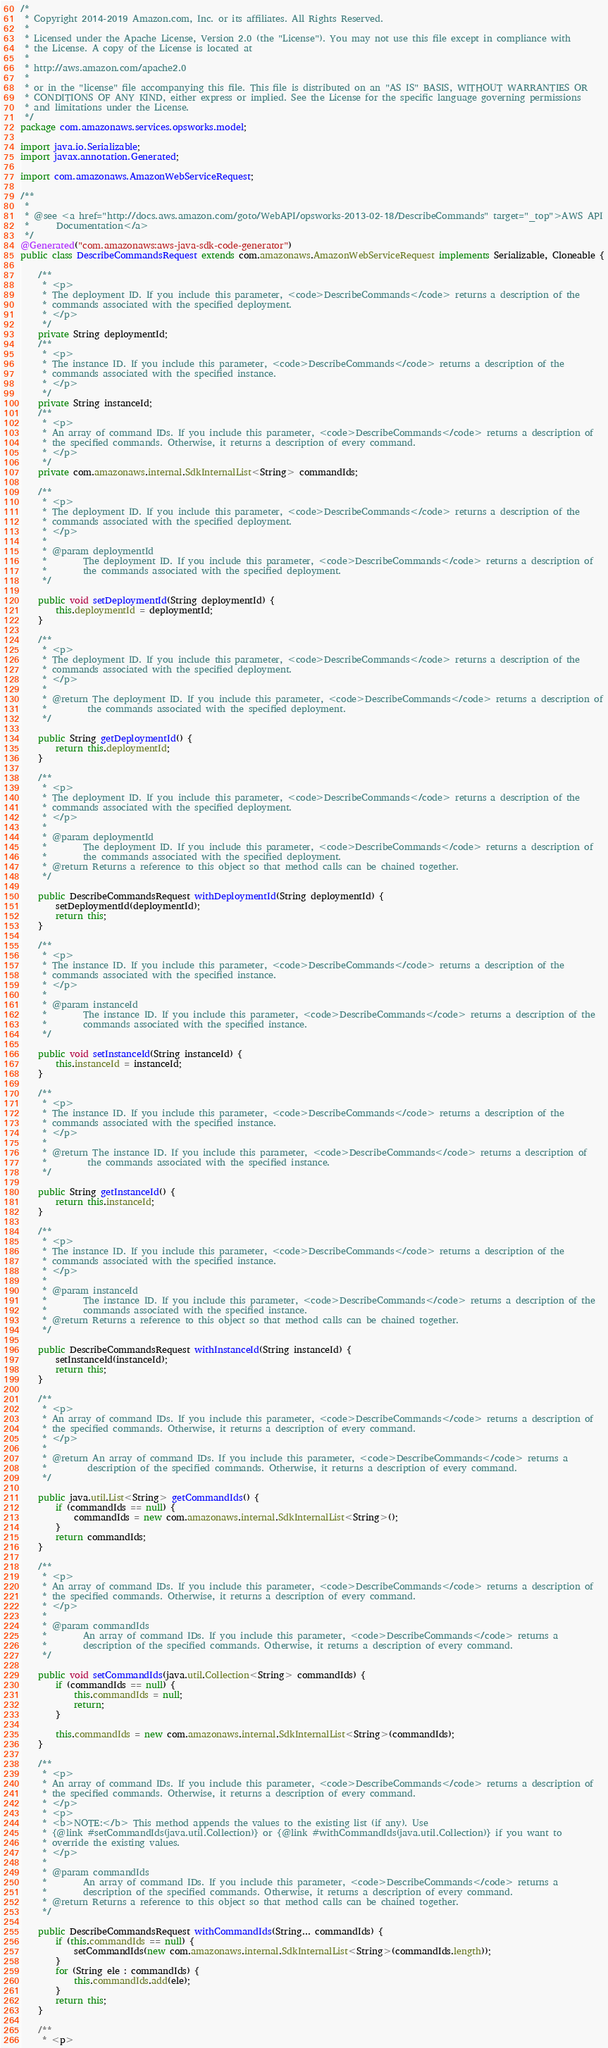Convert code to text. <code><loc_0><loc_0><loc_500><loc_500><_Java_>/*
 * Copyright 2014-2019 Amazon.com, Inc. or its affiliates. All Rights Reserved.
 * 
 * Licensed under the Apache License, Version 2.0 (the "License"). You may not use this file except in compliance with
 * the License. A copy of the License is located at
 * 
 * http://aws.amazon.com/apache2.0
 * 
 * or in the "license" file accompanying this file. This file is distributed on an "AS IS" BASIS, WITHOUT WARRANTIES OR
 * CONDITIONS OF ANY KIND, either express or implied. See the License for the specific language governing permissions
 * and limitations under the License.
 */
package com.amazonaws.services.opsworks.model;

import java.io.Serializable;
import javax.annotation.Generated;

import com.amazonaws.AmazonWebServiceRequest;

/**
 * 
 * @see <a href="http://docs.aws.amazon.com/goto/WebAPI/opsworks-2013-02-18/DescribeCommands" target="_top">AWS API
 *      Documentation</a>
 */
@Generated("com.amazonaws:aws-java-sdk-code-generator")
public class DescribeCommandsRequest extends com.amazonaws.AmazonWebServiceRequest implements Serializable, Cloneable {

    /**
     * <p>
     * The deployment ID. If you include this parameter, <code>DescribeCommands</code> returns a description of the
     * commands associated with the specified deployment.
     * </p>
     */
    private String deploymentId;
    /**
     * <p>
     * The instance ID. If you include this parameter, <code>DescribeCommands</code> returns a description of the
     * commands associated with the specified instance.
     * </p>
     */
    private String instanceId;
    /**
     * <p>
     * An array of command IDs. If you include this parameter, <code>DescribeCommands</code> returns a description of
     * the specified commands. Otherwise, it returns a description of every command.
     * </p>
     */
    private com.amazonaws.internal.SdkInternalList<String> commandIds;

    /**
     * <p>
     * The deployment ID. If you include this parameter, <code>DescribeCommands</code> returns a description of the
     * commands associated with the specified deployment.
     * </p>
     * 
     * @param deploymentId
     *        The deployment ID. If you include this parameter, <code>DescribeCommands</code> returns a description of
     *        the commands associated with the specified deployment.
     */

    public void setDeploymentId(String deploymentId) {
        this.deploymentId = deploymentId;
    }

    /**
     * <p>
     * The deployment ID. If you include this parameter, <code>DescribeCommands</code> returns a description of the
     * commands associated with the specified deployment.
     * </p>
     * 
     * @return The deployment ID. If you include this parameter, <code>DescribeCommands</code> returns a description of
     *         the commands associated with the specified deployment.
     */

    public String getDeploymentId() {
        return this.deploymentId;
    }

    /**
     * <p>
     * The deployment ID. If you include this parameter, <code>DescribeCommands</code> returns a description of the
     * commands associated with the specified deployment.
     * </p>
     * 
     * @param deploymentId
     *        The deployment ID. If you include this parameter, <code>DescribeCommands</code> returns a description of
     *        the commands associated with the specified deployment.
     * @return Returns a reference to this object so that method calls can be chained together.
     */

    public DescribeCommandsRequest withDeploymentId(String deploymentId) {
        setDeploymentId(deploymentId);
        return this;
    }

    /**
     * <p>
     * The instance ID. If you include this parameter, <code>DescribeCommands</code> returns a description of the
     * commands associated with the specified instance.
     * </p>
     * 
     * @param instanceId
     *        The instance ID. If you include this parameter, <code>DescribeCommands</code> returns a description of the
     *        commands associated with the specified instance.
     */

    public void setInstanceId(String instanceId) {
        this.instanceId = instanceId;
    }

    /**
     * <p>
     * The instance ID. If you include this parameter, <code>DescribeCommands</code> returns a description of the
     * commands associated with the specified instance.
     * </p>
     * 
     * @return The instance ID. If you include this parameter, <code>DescribeCommands</code> returns a description of
     *         the commands associated with the specified instance.
     */

    public String getInstanceId() {
        return this.instanceId;
    }

    /**
     * <p>
     * The instance ID. If you include this parameter, <code>DescribeCommands</code> returns a description of the
     * commands associated with the specified instance.
     * </p>
     * 
     * @param instanceId
     *        The instance ID. If you include this parameter, <code>DescribeCommands</code> returns a description of the
     *        commands associated with the specified instance.
     * @return Returns a reference to this object so that method calls can be chained together.
     */

    public DescribeCommandsRequest withInstanceId(String instanceId) {
        setInstanceId(instanceId);
        return this;
    }

    /**
     * <p>
     * An array of command IDs. If you include this parameter, <code>DescribeCommands</code> returns a description of
     * the specified commands. Otherwise, it returns a description of every command.
     * </p>
     * 
     * @return An array of command IDs. If you include this parameter, <code>DescribeCommands</code> returns a
     *         description of the specified commands. Otherwise, it returns a description of every command.
     */

    public java.util.List<String> getCommandIds() {
        if (commandIds == null) {
            commandIds = new com.amazonaws.internal.SdkInternalList<String>();
        }
        return commandIds;
    }

    /**
     * <p>
     * An array of command IDs. If you include this parameter, <code>DescribeCommands</code> returns a description of
     * the specified commands. Otherwise, it returns a description of every command.
     * </p>
     * 
     * @param commandIds
     *        An array of command IDs. If you include this parameter, <code>DescribeCommands</code> returns a
     *        description of the specified commands. Otherwise, it returns a description of every command.
     */

    public void setCommandIds(java.util.Collection<String> commandIds) {
        if (commandIds == null) {
            this.commandIds = null;
            return;
        }

        this.commandIds = new com.amazonaws.internal.SdkInternalList<String>(commandIds);
    }

    /**
     * <p>
     * An array of command IDs. If you include this parameter, <code>DescribeCommands</code> returns a description of
     * the specified commands. Otherwise, it returns a description of every command.
     * </p>
     * <p>
     * <b>NOTE:</b> This method appends the values to the existing list (if any). Use
     * {@link #setCommandIds(java.util.Collection)} or {@link #withCommandIds(java.util.Collection)} if you want to
     * override the existing values.
     * </p>
     * 
     * @param commandIds
     *        An array of command IDs. If you include this parameter, <code>DescribeCommands</code> returns a
     *        description of the specified commands. Otherwise, it returns a description of every command.
     * @return Returns a reference to this object so that method calls can be chained together.
     */

    public DescribeCommandsRequest withCommandIds(String... commandIds) {
        if (this.commandIds == null) {
            setCommandIds(new com.amazonaws.internal.SdkInternalList<String>(commandIds.length));
        }
        for (String ele : commandIds) {
            this.commandIds.add(ele);
        }
        return this;
    }

    /**
     * <p></code> 